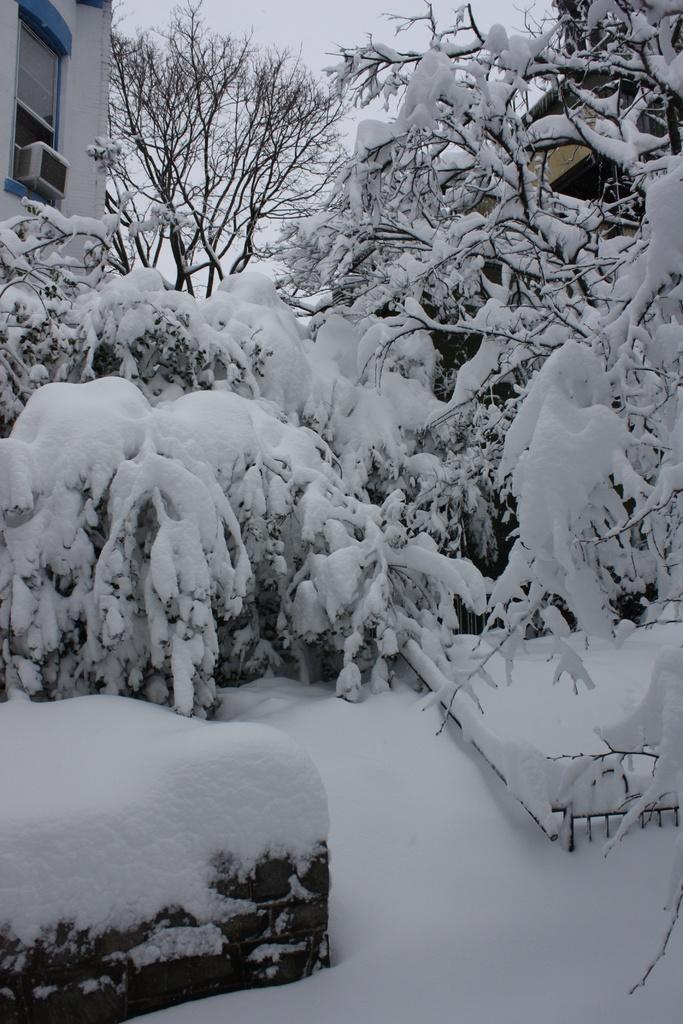In one or two sentences, can you explain what this image depicts? In this picture, we can see trees and the ground covered by snow and we can see some buildings with snow and we can see the sky. 